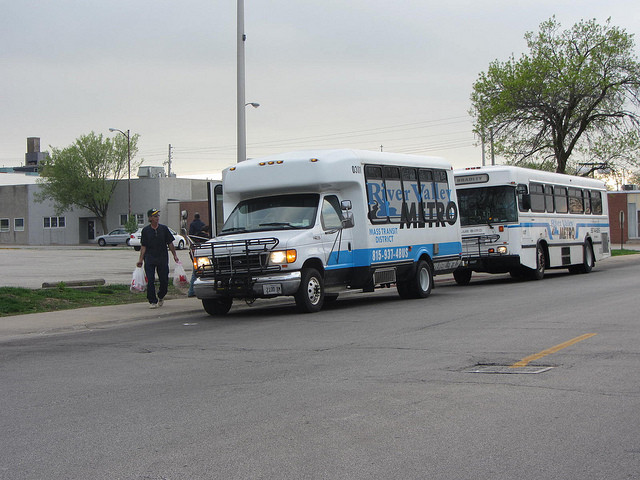Identify the text contained in this image. METRO River 4885 